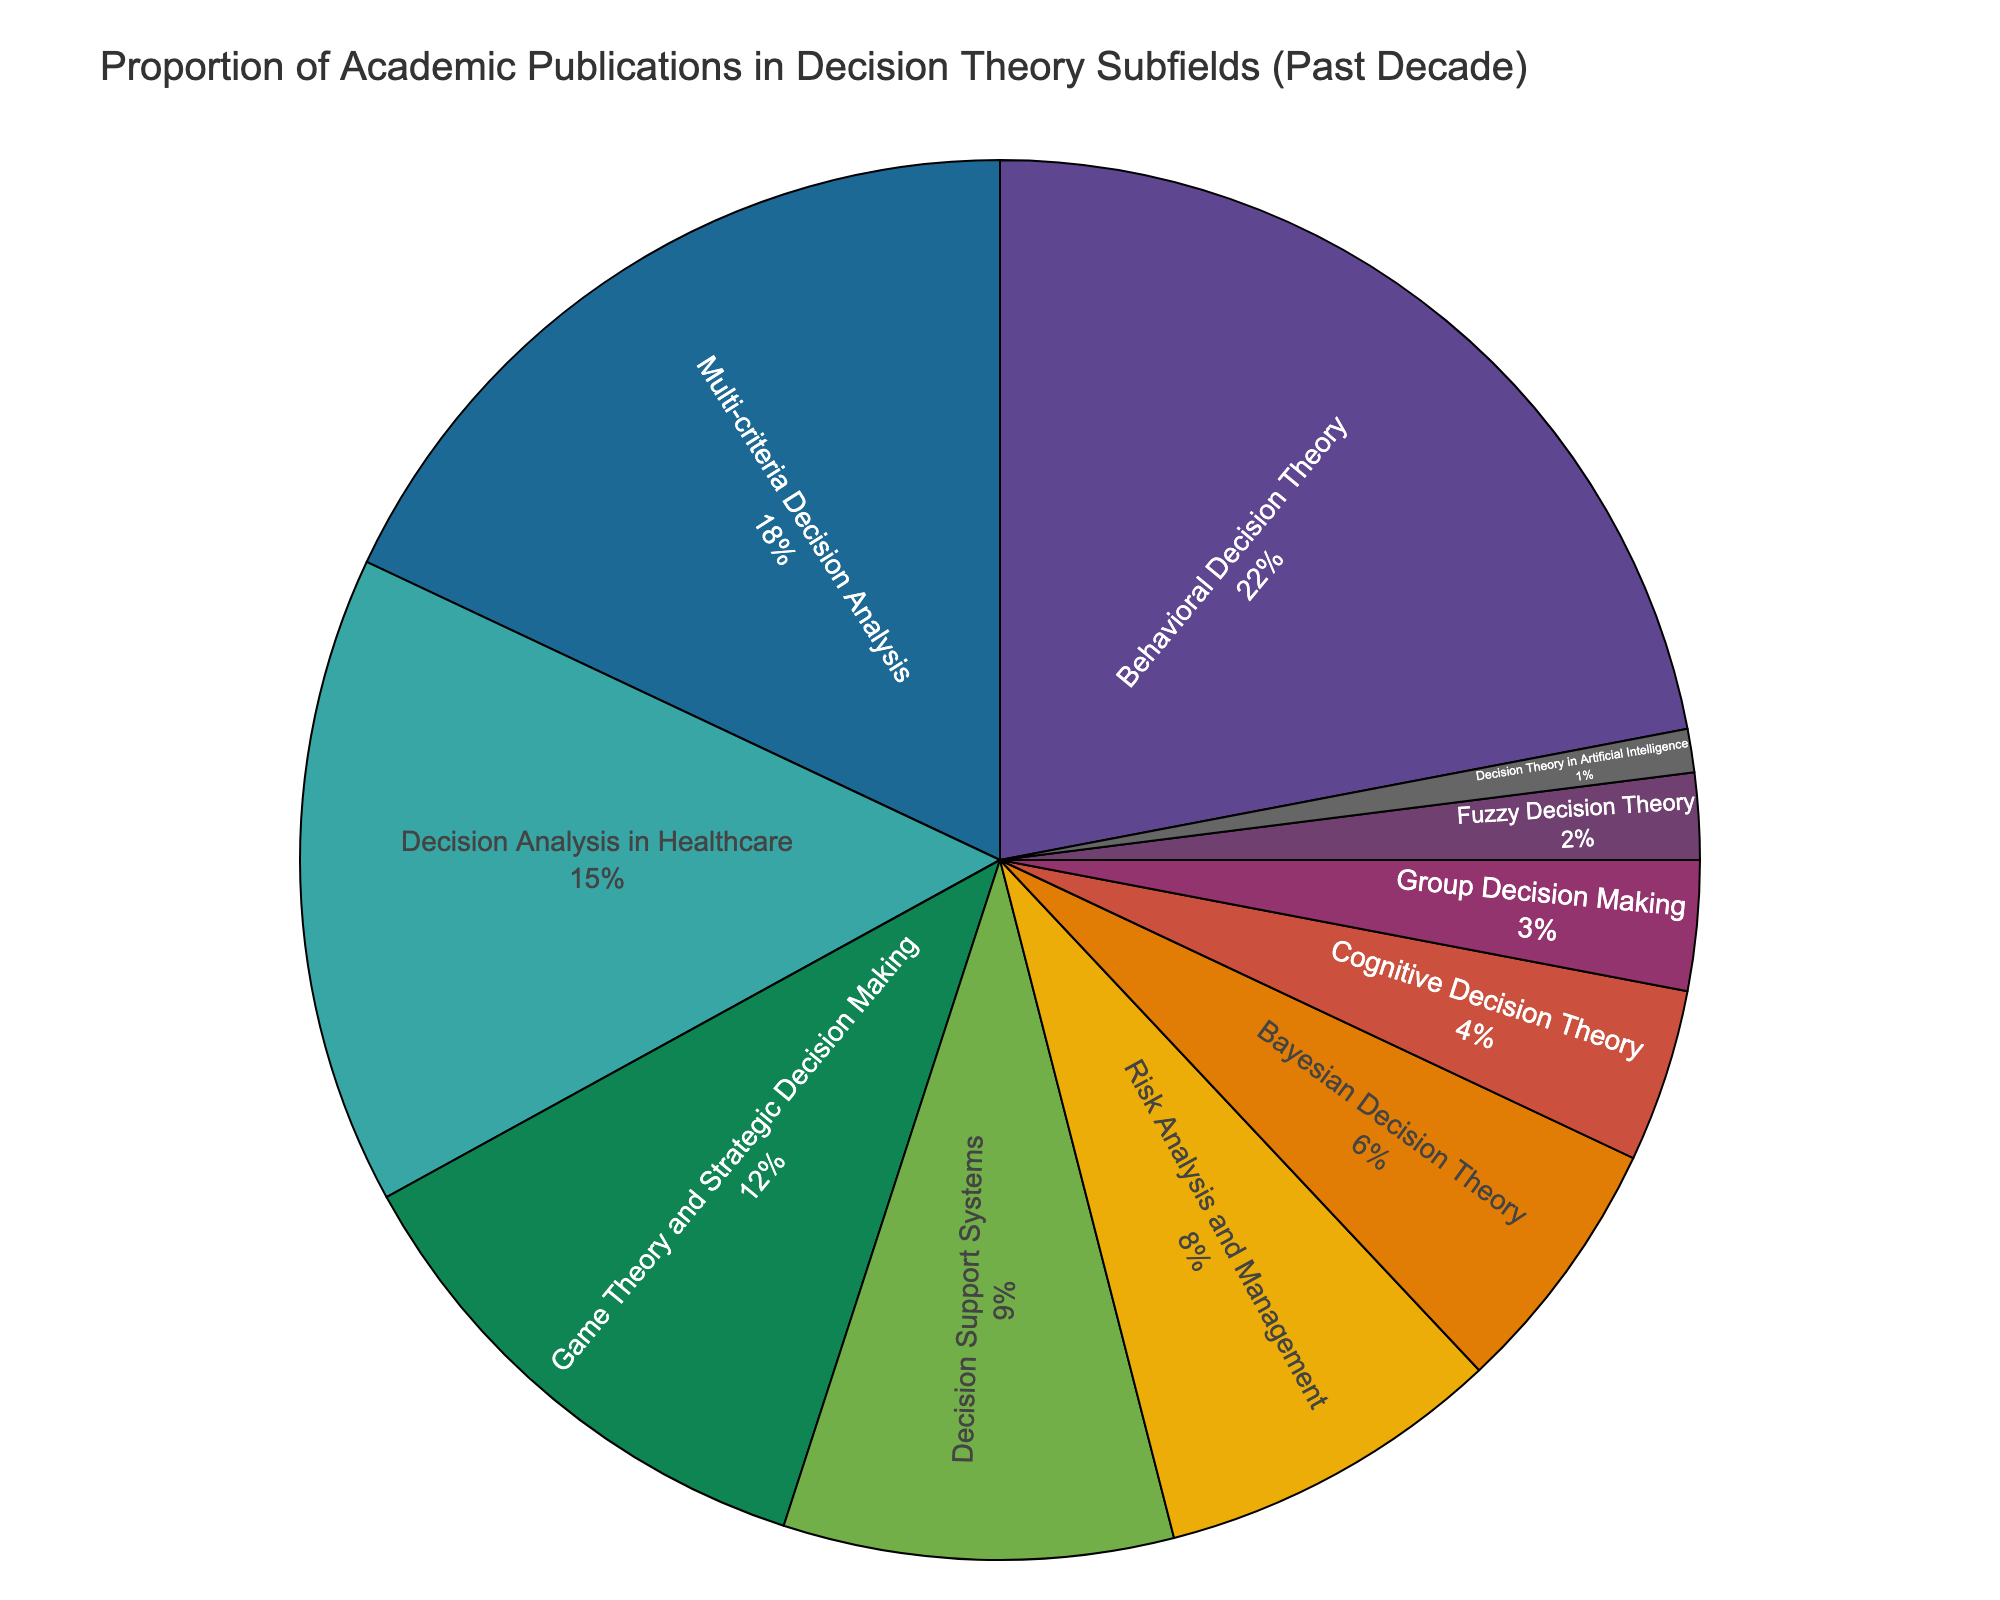Which subfield has the highest proportion of academic publications? By looking at the chart, the subfield with the largest segment is "Behavioral Decision Theory", indicating it has the highest proportion.
Answer: Behavioral Decision Theory Which two subfields together account for 30% of the academic publications? Adding proportions of Behavioral Decision Theory (22%) and Multi-criteria Decision Analysis (18%) gives us 40%, which is greater than 30%. Instead, adding Multi-criteria Decision Analysis (18%) and Decision Analysis in Healthcare (15%) yields 33%, still greater. Therefore, Decision Analysis in Healthcare (15%) and Game Theory and Strategic Decision Making (12%) sum up to 27%, which is less. Adding Game Theory (12%) and Decision Support Systems (9%) equals 21%. Combining Risk Analysis (8%) gets us closer. Summing Risk Analysis (8%) + Bayesian Decision Theory (6%) equals 14%. Summing Bayesian Decision Theory (6%) + Cognitive Decision Theory (4%) equals 10%. Hence the correct sums require Behavioral Decision (22%) + Bayesian Decision Theory (6%) equals 28%, which is closest.
Answer: Multi-criteria Decision Analysis and Decision Analysis in Healthcare What's the combined proportion of publications in subfields related to decision-making in healthcare and risk management? Summing the proportions of "Decision Analysis in Healthcare" (15%) and "Risk Analysis and Management" (8%) yields a total of 23%.
Answer: 23% What is the proportion difference between the top subfield and the subfield with the lowest proportion? Subtract the proportion of the smallest, "Decision Theory in Artificial Intelligence" (1%), from the highest, "Behavioral Decision Theory" (22%). 22% - 1% = 21%.
Answer: 21% Are there more publications in Bayesian Decision Theory than Group Decision Making? The chart shows Bayesian Decision Theory with a proportion of 6% and Group Decision Making with a proportion of 3%. Since 6% is greater than 3%, Bayesian Decision Theory has more publications.
Answer: Yes What is the visual pattern of the subfield with the second-largest proportion? The second-largest proportion is Multi-criteria Decision Analysis (18%). Its segment in the pie chart is visually smaller than Behavioral Decision Theory but larger than all the other subfields.
Answer: Multi-criteria Decision Analysis Which subfields combined make up less than 10% of the publications? Summing the proportions of "Group Decision Making" (3%), "Fuzzy Decision Theory" (2%), and "Decision Theory in Artificial Intelligence" (1%) yields a total of 6%, which is less than 10%.
Answer: Group Decision Making, Fuzzy Decision Theory, and Decision Theory in Artificial Intelligence What is the color of the segment representing Cognitive Decision Theory? By examining the pie chart, you can identify Cognitive Decision Theory (4%) and its corresponding color.
Answer: [Color of the Cognitive Decision Theory segment from the pie chart] How many subfields have a proportion equal to or less than 5%? The chart shows Cognitive Decision Theory (4%), Group Decision Making (3%), Fuzzy Decision Theory (2%), and Decision Theory in Artificial Intelligence (1%), making a total of 4 subfields with proportions less than or equal to 5%.
Answer: 4 